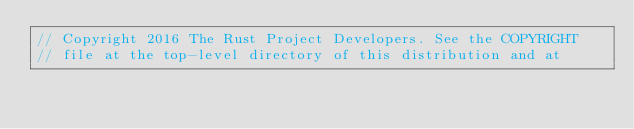<code> <loc_0><loc_0><loc_500><loc_500><_Rust_>// Copyright 2016 The Rust Project Developers. See the COPYRIGHT
// file at the top-level directory of this distribution and at</code> 